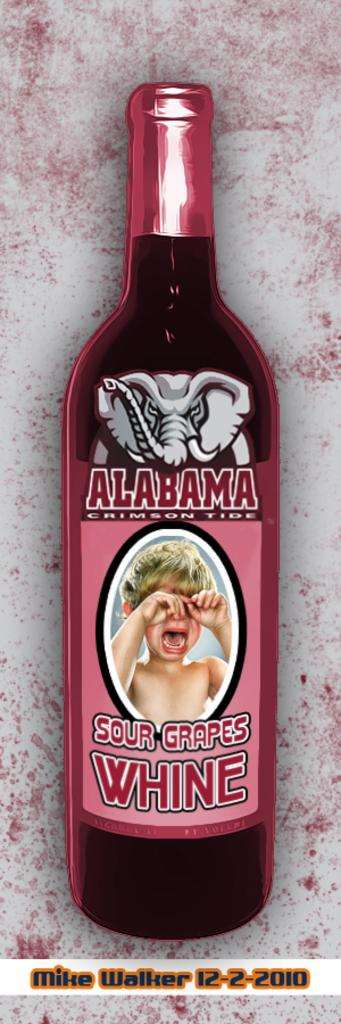Provide a one-sentence caption for the provided image. A bottle of Alabama Sour Grapes Wine with a crying baby on the label. 